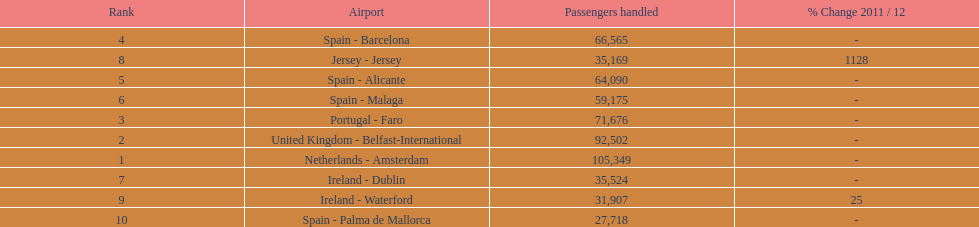Which airport has no more than 30,000 passengers handled among the 10 busiest routes to and from london southend airport in 2012? Spain - Palma de Mallorca. 